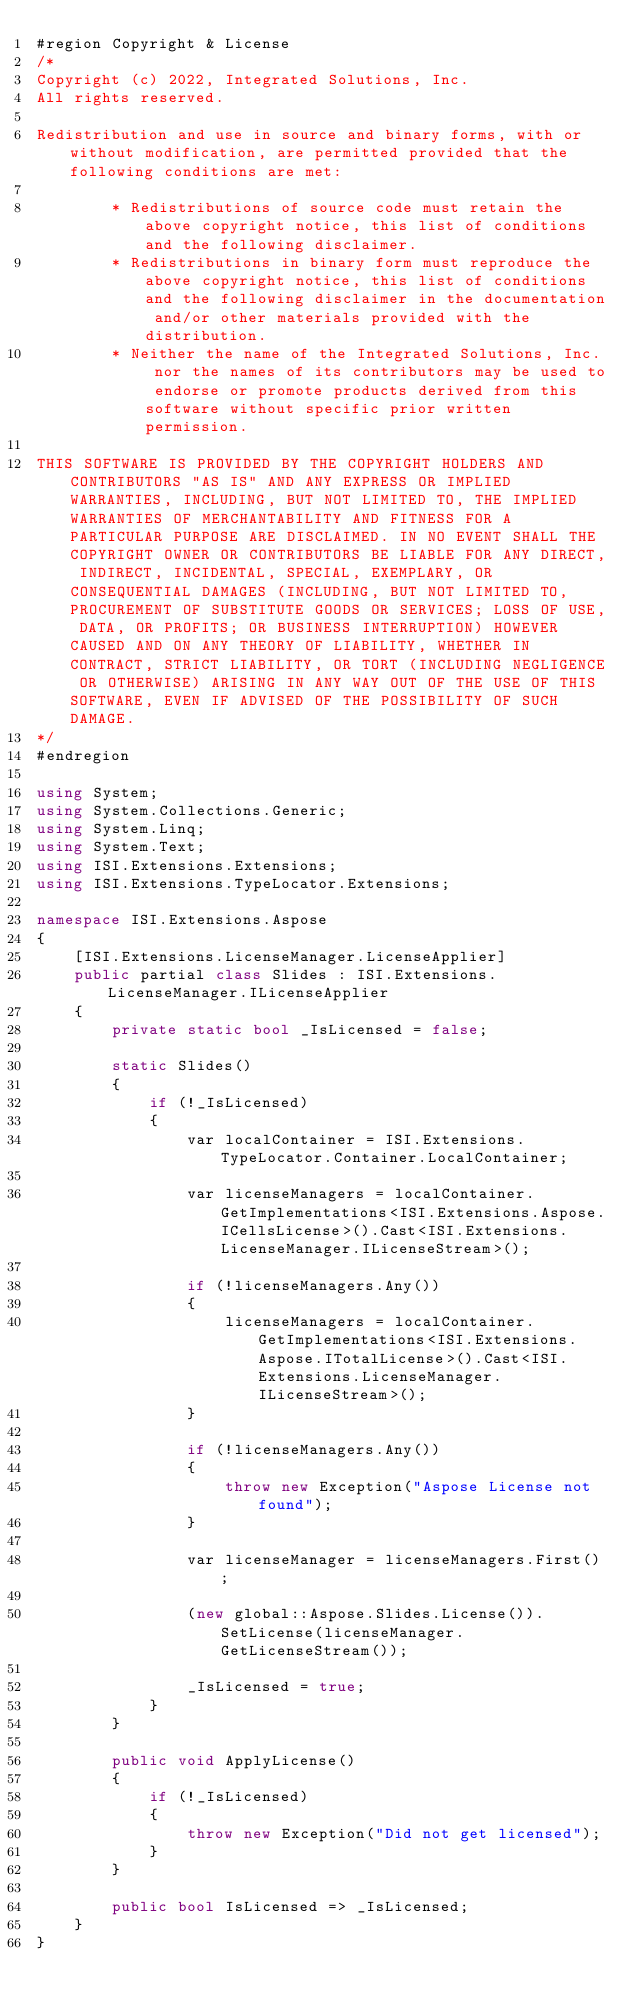<code> <loc_0><loc_0><loc_500><loc_500><_C#_>#region Copyright & License
/*
Copyright (c) 2022, Integrated Solutions, Inc.
All rights reserved.

Redistribution and use in source and binary forms, with or without modification, are permitted provided that the following conditions are met:

		* Redistributions of source code must retain the above copyright notice, this list of conditions and the following disclaimer.
		* Redistributions in binary form must reproduce the above copyright notice, this list of conditions and the following disclaimer in the documentation and/or other materials provided with the distribution.
		* Neither the name of the Integrated Solutions, Inc. nor the names of its contributors may be used to endorse or promote products derived from this software without specific prior written permission.

THIS SOFTWARE IS PROVIDED BY THE COPYRIGHT HOLDERS AND CONTRIBUTORS "AS IS" AND ANY EXPRESS OR IMPLIED WARRANTIES, INCLUDING, BUT NOT LIMITED TO, THE IMPLIED WARRANTIES OF MERCHANTABILITY AND FITNESS FOR A PARTICULAR PURPOSE ARE DISCLAIMED. IN NO EVENT SHALL THE COPYRIGHT OWNER OR CONTRIBUTORS BE LIABLE FOR ANY DIRECT, INDIRECT, INCIDENTAL, SPECIAL, EXEMPLARY, OR CONSEQUENTIAL DAMAGES (INCLUDING, BUT NOT LIMITED TO, PROCUREMENT OF SUBSTITUTE GOODS OR SERVICES; LOSS OF USE, DATA, OR PROFITS; OR BUSINESS INTERRUPTION) HOWEVER CAUSED AND ON ANY THEORY OF LIABILITY, WHETHER IN CONTRACT, STRICT LIABILITY, OR TORT (INCLUDING NEGLIGENCE OR OTHERWISE) ARISING IN ANY WAY OUT OF THE USE OF THIS SOFTWARE, EVEN IF ADVISED OF THE POSSIBILITY OF SUCH DAMAGE.
*/
#endregion
 
using System;
using System.Collections.Generic;
using System.Linq;
using System.Text;
using ISI.Extensions.Extensions;
using ISI.Extensions.TypeLocator.Extensions;

namespace ISI.Extensions.Aspose
{
	[ISI.Extensions.LicenseManager.LicenseApplier]
	public partial class Slides : ISI.Extensions.LicenseManager.ILicenseApplier
	{
		private static bool _IsLicensed = false;

		static Slides()
		{
			if (!_IsLicensed)
			{
				var localContainer = ISI.Extensions.TypeLocator.Container.LocalContainer;

				var licenseManagers = localContainer.GetImplementations<ISI.Extensions.Aspose.ICellsLicense>().Cast<ISI.Extensions.LicenseManager.ILicenseStream>();
				
				if (!licenseManagers.Any())
				{
					licenseManagers = localContainer.GetImplementations<ISI.Extensions.Aspose.ITotalLicense>().Cast<ISI.Extensions.LicenseManager.ILicenseStream>();
				}

				if (!licenseManagers.Any())
				{
					throw new Exception("Aspose License not found");
				}

				var licenseManager = licenseManagers.First();

				(new global::Aspose.Slides.License()).SetLicense(licenseManager.GetLicenseStream());

				_IsLicensed = true;
			}
		}

		public void ApplyLicense()
		{
			if (!_IsLicensed)
			{
				throw new Exception("Did not get licensed");
			}
		}

		public bool IsLicensed => _IsLicensed;
	}
}
</code> 